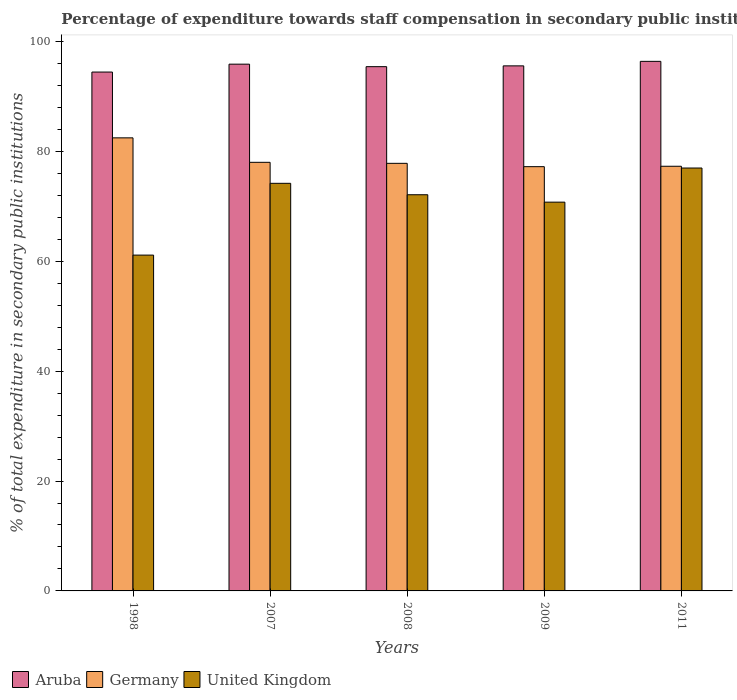How many different coloured bars are there?
Ensure brevity in your answer.  3. How many groups of bars are there?
Provide a short and direct response. 5. Are the number of bars on each tick of the X-axis equal?
Offer a terse response. Yes. How many bars are there on the 2nd tick from the left?
Provide a short and direct response. 3. What is the label of the 4th group of bars from the left?
Offer a very short reply. 2009. What is the percentage of expenditure towards staff compensation in Germany in 2009?
Offer a terse response. 77.21. Across all years, what is the maximum percentage of expenditure towards staff compensation in United Kingdom?
Keep it short and to the point. 76.96. Across all years, what is the minimum percentage of expenditure towards staff compensation in Aruba?
Keep it short and to the point. 94.42. In which year was the percentage of expenditure towards staff compensation in Aruba maximum?
Make the answer very short. 2011. What is the total percentage of expenditure towards staff compensation in United Kingdom in the graph?
Ensure brevity in your answer.  355.1. What is the difference between the percentage of expenditure towards staff compensation in Aruba in 2008 and that in 2009?
Your answer should be very brief. -0.15. What is the difference between the percentage of expenditure towards staff compensation in Germany in 2011 and the percentage of expenditure towards staff compensation in Aruba in 2008?
Provide a succinct answer. -18.12. What is the average percentage of expenditure towards staff compensation in United Kingdom per year?
Offer a very short reply. 71.02. In the year 2008, what is the difference between the percentage of expenditure towards staff compensation in United Kingdom and percentage of expenditure towards staff compensation in Germany?
Your answer should be very brief. -5.71. In how many years, is the percentage of expenditure towards staff compensation in United Kingdom greater than 32 %?
Your answer should be compact. 5. What is the ratio of the percentage of expenditure towards staff compensation in Germany in 2007 to that in 2008?
Your response must be concise. 1. Is the percentage of expenditure towards staff compensation in Aruba in 2008 less than that in 2011?
Provide a short and direct response. Yes. What is the difference between the highest and the second highest percentage of expenditure towards staff compensation in United Kingdom?
Provide a short and direct response. 2.79. What is the difference between the highest and the lowest percentage of expenditure towards staff compensation in Aruba?
Ensure brevity in your answer.  1.95. Is the sum of the percentage of expenditure towards staff compensation in United Kingdom in 2008 and 2011 greater than the maximum percentage of expenditure towards staff compensation in Aruba across all years?
Offer a terse response. Yes. What does the 1st bar from the left in 2009 represents?
Offer a terse response. Aruba. How many bars are there?
Provide a short and direct response. 15. Where does the legend appear in the graph?
Keep it short and to the point. Bottom left. What is the title of the graph?
Your response must be concise. Percentage of expenditure towards staff compensation in secondary public institutions. Does "Liechtenstein" appear as one of the legend labels in the graph?
Provide a short and direct response. No. What is the label or title of the Y-axis?
Your answer should be very brief. % of total expenditure in secondary public institutions. What is the % of total expenditure in secondary public institutions in Aruba in 1998?
Make the answer very short. 94.42. What is the % of total expenditure in secondary public institutions in Germany in 1998?
Offer a very short reply. 82.45. What is the % of total expenditure in secondary public institutions of United Kingdom in 1998?
Provide a short and direct response. 61.11. What is the % of total expenditure in secondary public institutions of Aruba in 2007?
Give a very brief answer. 95.86. What is the % of total expenditure in secondary public institutions in Germany in 2007?
Your answer should be very brief. 78. What is the % of total expenditure in secondary public institutions of United Kingdom in 2007?
Give a very brief answer. 74.18. What is the % of total expenditure in secondary public institutions of Aruba in 2008?
Offer a terse response. 95.41. What is the % of total expenditure in secondary public institutions of Germany in 2008?
Provide a short and direct response. 77.81. What is the % of total expenditure in secondary public institutions of United Kingdom in 2008?
Keep it short and to the point. 72.1. What is the % of total expenditure in secondary public institutions in Aruba in 2009?
Give a very brief answer. 95.55. What is the % of total expenditure in secondary public institutions of Germany in 2009?
Keep it short and to the point. 77.21. What is the % of total expenditure in secondary public institutions of United Kingdom in 2009?
Offer a very short reply. 70.75. What is the % of total expenditure in secondary public institutions in Aruba in 2011?
Your response must be concise. 96.37. What is the % of total expenditure in secondary public institutions of Germany in 2011?
Provide a succinct answer. 77.28. What is the % of total expenditure in secondary public institutions in United Kingdom in 2011?
Your answer should be compact. 76.96. Across all years, what is the maximum % of total expenditure in secondary public institutions of Aruba?
Make the answer very short. 96.37. Across all years, what is the maximum % of total expenditure in secondary public institutions in Germany?
Offer a very short reply. 82.45. Across all years, what is the maximum % of total expenditure in secondary public institutions of United Kingdom?
Ensure brevity in your answer.  76.96. Across all years, what is the minimum % of total expenditure in secondary public institutions of Aruba?
Offer a very short reply. 94.42. Across all years, what is the minimum % of total expenditure in secondary public institutions of Germany?
Your response must be concise. 77.21. Across all years, what is the minimum % of total expenditure in secondary public institutions of United Kingdom?
Provide a short and direct response. 61.11. What is the total % of total expenditure in secondary public institutions of Aruba in the graph?
Give a very brief answer. 477.61. What is the total % of total expenditure in secondary public institutions of Germany in the graph?
Your answer should be compact. 392.75. What is the total % of total expenditure in secondary public institutions of United Kingdom in the graph?
Your response must be concise. 355.1. What is the difference between the % of total expenditure in secondary public institutions of Aruba in 1998 and that in 2007?
Ensure brevity in your answer.  -1.44. What is the difference between the % of total expenditure in secondary public institutions in Germany in 1998 and that in 2007?
Your response must be concise. 4.45. What is the difference between the % of total expenditure in secondary public institutions of United Kingdom in 1998 and that in 2007?
Your answer should be very brief. -13.06. What is the difference between the % of total expenditure in secondary public institutions of Aruba in 1998 and that in 2008?
Make the answer very short. -0.98. What is the difference between the % of total expenditure in secondary public institutions in Germany in 1998 and that in 2008?
Give a very brief answer. 4.64. What is the difference between the % of total expenditure in secondary public institutions in United Kingdom in 1998 and that in 2008?
Make the answer very short. -10.99. What is the difference between the % of total expenditure in secondary public institutions of Aruba in 1998 and that in 2009?
Make the answer very short. -1.13. What is the difference between the % of total expenditure in secondary public institutions in Germany in 1998 and that in 2009?
Offer a terse response. 5.24. What is the difference between the % of total expenditure in secondary public institutions in United Kingdom in 1998 and that in 2009?
Your answer should be compact. -9.64. What is the difference between the % of total expenditure in secondary public institutions of Aruba in 1998 and that in 2011?
Provide a short and direct response. -1.95. What is the difference between the % of total expenditure in secondary public institutions of Germany in 1998 and that in 2011?
Your response must be concise. 5.17. What is the difference between the % of total expenditure in secondary public institutions of United Kingdom in 1998 and that in 2011?
Offer a terse response. -15.85. What is the difference between the % of total expenditure in secondary public institutions of Aruba in 2007 and that in 2008?
Offer a terse response. 0.46. What is the difference between the % of total expenditure in secondary public institutions of Germany in 2007 and that in 2008?
Your answer should be very brief. 0.18. What is the difference between the % of total expenditure in secondary public institutions of United Kingdom in 2007 and that in 2008?
Your answer should be very brief. 2.08. What is the difference between the % of total expenditure in secondary public institutions of Aruba in 2007 and that in 2009?
Make the answer very short. 0.31. What is the difference between the % of total expenditure in secondary public institutions of Germany in 2007 and that in 2009?
Make the answer very short. 0.79. What is the difference between the % of total expenditure in secondary public institutions of United Kingdom in 2007 and that in 2009?
Make the answer very short. 3.43. What is the difference between the % of total expenditure in secondary public institutions of Aruba in 2007 and that in 2011?
Offer a terse response. -0.51. What is the difference between the % of total expenditure in secondary public institutions of Germany in 2007 and that in 2011?
Offer a terse response. 0.72. What is the difference between the % of total expenditure in secondary public institutions of United Kingdom in 2007 and that in 2011?
Keep it short and to the point. -2.79. What is the difference between the % of total expenditure in secondary public institutions in Aruba in 2008 and that in 2009?
Keep it short and to the point. -0.15. What is the difference between the % of total expenditure in secondary public institutions in Germany in 2008 and that in 2009?
Your answer should be compact. 0.61. What is the difference between the % of total expenditure in secondary public institutions in United Kingdom in 2008 and that in 2009?
Offer a terse response. 1.35. What is the difference between the % of total expenditure in secondary public institutions in Aruba in 2008 and that in 2011?
Your response must be concise. -0.97. What is the difference between the % of total expenditure in secondary public institutions of Germany in 2008 and that in 2011?
Provide a succinct answer. 0.53. What is the difference between the % of total expenditure in secondary public institutions of United Kingdom in 2008 and that in 2011?
Give a very brief answer. -4.86. What is the difference between the % of total expenditure in secondary public institutions of Aruba in 2009 and that in 2011?
Keep it short and to the point. -0.82. What is the difference between the % of total expenditure in secondary public institutions in Germany in 2009 and that in 2011?
Make the answer very short. -0.07. What is the difference between the % of total expenditure in secondary public institutions in United Kingdom in 2009 and that in 2011?
Provide a short and direct response. -6.21. What is the difference between the % of total expenditure in secondary public institutions in Aruba in 1998 and the % of total expenditure in secondary public institutions in Germany in 2007?
Your response must be concise. 16.43. What is the difference between the % of total expenditure in secondary public institutions of Aruba in 1998 and the % of total expenditure in secondary public institutions of United Kingdom in 2007?
Offer a very short reply. 20.25. What is the difference between the % of total expenditure in secondary public institutions in Germany in 1998 and the % of total expenditure in secondary public institutions in United Kingdom in 2007?
Your answer should be compact. 8.28. What is the difference between the % of total expenditure in secondary public institutions in Aruba in 1998 and the % of total expenditure in secondary public institutions in Germany in 2008?
Make the answer very short. 16.61. What is the difference between the % of total expenditure in secondary public institutions of Aruba in 1998 and the % of total expenditure in secondary public institutions of United Kingdom in 2008?
Offer a very short reply. 22.33. What is the difference between the % of total expenditure in secondary public institutions of Germany in 1998 and the % of total expenditure in secondary public institutions of United Kingdom in 2008?
Your answer should be compact. 10.35. What is the difference between the % of total expenditure in secondary public institutions of Aruba in 1998 and the % of total expenditure in secondary public institutions of Germany in 2009?
Your response must be concise. 17.22. What is the difference between the % of total expenditure in secondary public institutions of Aruba in 1998 and the % of total expenditure in secondary public institutions of United Kingdom in 2009?
Your answer should be compact. 23.68. What is the difference between the % of total expenditure in secondary public institutions in Germany in 1998 and the % of total expenditure in secondary public institutions in United Kingdom in 2009?
Your answer should be very brief. 11.7. What is the difference between the % of total expenditure in secondary public institutions in Aruba in 1998 and the % of total expenditure in secondary public institutions in Germany in 2011?
Keep it short and to the point. 17.14. What is the difference between the % of total expenditure in secondary public institutions of Aruba in 1998 and the % of total expenditure in secondary public institutions of United Kingdom in 2011?
Keep it short and to the point. 17.46. What is the difference between the % of total expenditure in secondary public institutions in Germany in 1998 and the % of total expenditure in secondary public institutions in United Kingdom in 2011?
Your response must be concise. 5.49. What is the difference between the % of total expenditure in secondary public institutions in Aruba in 2007 and the % of total expenditure in secondary public institutions in Germany in 2008?
Offer a terse response. 18.05. What is the difference between the % of total expenditure in secondary public institutions in Aruba in 2007 and the % of total expenditure in secondary public institutions in United Kingdom in 2008?
Your answer should be compact. 23.76. What is the difference between the % of total expenditure in secondary public institutions of Germany in 2007 and the % of total expenditure in secondary public institutions of United Kingdom in 2008?
Give a very brief answer. 5.9. What is the difference between the % of total expenditure in secondary public institutions of Aruba in 2007 and the % of total expenditure in secondary public institutions of Germany in 2009?
Keep it short and to the point. 18.65. What is the difference between the % of total expenditure in secondary public institutions of Aruba in 2007 and the % of total expenditure in secondary public institutions of United Kingdom in 2009?
Provide a short and direct response. 25.11. What is the difference between the % of total expenditure in secondary public institutions in Germany in 2007 and the % of total expenditure in secondary public institutions in United Kingdom in 2009?
Provide a short and direct response. 7.25. What is the difference between the % of total expenditure in secondary public institutions in Aruba in 2007 and the % of total expenditure in secondary public institutions in Germany in 2011?
Your response must be concise. 18.58. What is the difference between the % of total expenditure in secondary public institutions in Aruba in 2007 and the % of total expenditure in secondary public institutions in United Kingdom in 2011?
Your answer should be very brief. 18.9. What is the difference between the % of total expenditure in secondary public institutions in Germany in 2007 and the % of total expenditure in secondary public institutions in United Kingdom in 2011?
Your response must be concise. 1.04. What is the difference between the % of total expenditure in secondary public institutions of Aruba in 2008 and the % of total expenditure in secondary public institutions of Germany in 2009?
Provide a succinct answer. 18.2. What is the difference between the % of total expenditure in secondary public institutions in Aruba in 2008 and the % of total expenditure in secondary public institutions in United Kingdom in 2009?
Make the answer very short. 24.66. What is the difference between the % of total expenditure in secondary public institutions in Germany in 2008 and the % of total expenditure in secondary public institutions in United Kingdom in 2009?
Your answer should be compact. 7.06. What is the difference between the % of total expenditure in secondary public institutions of Aruba in 2008 and the % of total expenditure in secondary public institutions of Germany in 2011?
Your response must be concise. 18.12. What is the difference between the % of total expenditure in secondary public institutions of Aruba in 2008 and the % of total expenditure in secondary public institutions of United Kingdom in 2011?
Your answer should be very brief. 18.45. What is the difference between the % of total expenditure in secondary public institutions in Germany in 2008 and the % of total expenditure in secondary public institutions in United Kingdom in 2011?
Offer a very short reply. 0.85. What is the difference between the % of total expenditure in secondary public institutions of Aruba in 2009 and the % of total expenditure in secondary public institutions of Germany in 2011?
Make the answer very short. 18.27. What is the difference between the % of total expenditure in secondary public institutions of Aruba in 2009 and the % of total expenditure in secondary public institutions of United Kingdom in 2011?
Provide a short and direct response. 18.59. What is the difference between the % of total expenditure in secondary public institutions in Germany in 2009 and the % of total expenditure in secondary public institutions in United Kingdom in 2011?
Keep it short and to the point. 0.25. What is the average % of total expenditure in secondary public institutions in Aruba per year?
Your answer should be compact. 95.52. What is the average % of total expenditure in secondary public institutions in Germany per year?
Provide a short and direct response. 78.55. What is the average % of total expenditure in secondary public institutions in United Kingdom per year?
Offer a very short reply. 71.02. In the year 1998, what is the difference between the % of total expenditure in secondary public institutions of Aruba and % of total expenditure in secondary public institutions of Germany?
Keep it short and to the point. 11.97. In the year 1998, what is the difference between the % of total expenditure in secondary public institutions in Aruba and % of total expenditure in secondary public institutions in United Kingdom?
Offer a terse response. 33.31. In the year 1998, what is the difference between the % of total expenditure in secondary public institutions in Germany and % of total expenditure in secondary public institutions in United Kingdom?
Provide a succinct answer. 21.34. In the year 2007, what is the difference between the % of total expenditure in secondary public institutions in Aruba and % of total expenditure in secondary public institutions in Germany?
Your answer should be very brief. 17.86. In the year 2007, what is the difference between the % of total expenditure in secondary public institutions of Aruba and % of total expenditure in secondary public institutions of United Kingdom?
Keep it short and to the point. 21.69. In the year 2007, what is the difference between the % of total expenditure in secondary public institutions of Germany and % of total expenditure in secondary public institutions of United Kingdom?
Your response must be concise. 3.82. In the year 2008, what is the difference between the % of total expenditure in secondary public institutions in Aruba and % of total expenditure in secondary public institutions in Germany?
Your answer should be compact. 17.59. In the year 2008, what is the difference between the % of total expenditure in secondary public institutions of Aruba and % of total expenditure in secondary public institutions of United Kingdom?
Give a very brief answer. 23.31. In the year 2008, what is the difference between the % of total expenditure in secondary public institutions of Germany and % of total expenditure in secondary public institutions of United Kingdom?
Offer a very short reply. 5.71. In the year 2009, what is the difference between the % of total expenditure in secondary public institutions of Aruba and % of total expenditure in secondary public institutions of Germany?
Offer a terse response. 18.34. In the year 2009, what is the difference between the % of total expenditure in secondary public institutions of Aruba and % of total expenditure in secondary public institutions of United Kingdom?
Make the answer very short. 24.8. In the year 2009, what is the difference between the % of total expenditure in secondary public institutions of Germany and % of total expenditure in secondary public institutions of United Kingdom?
Your answer should be compact. 6.46. In the year 2011, what is the difference between the % of total expenditure in secondary public institutions in Aruba and % of total expenditure in secondary public institutions in Germany?
Your answer should be compact. 19.09. In the year 2011, what is the difference between the % of total expenditure in secondary public institutions in Aruba and % of total expenditure in secondary public institutions in United Kingdom?
Provide a short and direct response. 19.41. In the year 2011, what is the difference between the % of total expenditure in secondary public institutions in Germany and % of total expenditure in secondary public institutions in United Kingdom?
Offer a terse response. 0.32. What is the ratio of the % of total expenditure in secondary public institutions of Aruba in 1998 to that in 2007?
Your answer should be compact. 0.98. What is the ratio of the % of total expenditure in secondary public institutions in Germany in 1998 to that in 2007?
Offer a very short reply. 1.06. What is the ratio of the % of total expenditure in secondary public institutions in United Kingdom in 1998 to that in 2007?
Offer a very short reply. 0.82. What is the ratio of the % of total expenditure in secondary public institutions of Aruba in 1998 to that in 2008?
Provide a succinct answer. 0.99. What is the ratio of the % of total expenditure in secondary public institutions in Germany in 1998 to that in 2008?
Provide a short and direct response. 1.06. What is the ratio of the % of total expenditure in secondary public institutions of United Kingdom in 1998 to that in 2008?
Your answer should be compact. 0.85. What is the ratio of the % of total expenditure in secondary public institutions of Germany in 1998 to that in 2009?
Make the answer very short. 1.07. What is the ratio of the % of total expenditure in secondary public institutions in United Kingdom in 1998 to that in 2009?
Keep it short and to the point. 0.86. What is the ratio of the % of total expenditure in secondary public institutions in Aruba in 1998 to that in 2011?
Your answer should be very brief. 0.98. What is the ratio of the % of total expenditure in secondary public institutions of Germany in 1998 to that in 2011?
Your answer should be compact. 1.07. What is the ratio of the % of total expenditure in secondary public institutions in United Kingdom in 1998 to that in 2011?
Give a very brief answer. 0.79. What is the ratio of the % of total expenditure in secondary public institutions in Aruba in 2007 to that in 2008?
Ensure brevity in your answer.  1. What is the ratio of the % of total expenditure in secondary public institutions of Germany in 2007 to that in 2008?
Make the answer very short. 1. What is the ratio of the % of total expenditure in secondary public institutions in United Kingdom in 2007 to that in 2008?
Ensure brevity in your answer.  1.03. What is the ratio of the % of total expenditure in secondary public institutions in Aruba in 2007 to that in 2009?
Provide a succinct answer. 1. What is the ratio of the % of total expenditure in secondary public institutions of Germany in 2007 to that in 2009?
Offer a terse response. 1.01. What is the ratio of the % of total expenditure in secondary public institutions in United Kingdom in 2007 to that in 2009?
Your response must be concise. 1.05. What is the ratio of the % of total expenditure in secondary public institutions in Aruba in 2007 to that in 2011?
Keep it short and to the point. 0.99. What is the ratio of the % of total expenditure in secondary public institutions in Germany in 2007 to that in 2011?
Ensure brevity in your answer.  1.01. What is the ratio of the % of total expenditure in secondary public institutions in United Kingdom in 2007 to that in 2011?
Make the answer very short. 0.96. What is the ratio of the % of total expenditure in secondary public institutions in Germany in 2008 to that in 2009?
Ensure brevity in your answer.  1.01. What is the ratio of the % of total expenditure in secondary public institutions of United Kingdom in 2008 to that in 2009?
Give a very brief answer. 1.02. What is the ratio of the % of total expenditure in secondary public institutions in Aruba in 2008 to that in 2011?
Ensure brevity in your answer.  0.99. What is the ratio of the % of total expenditure in secondary public institutions in United Kingdom in 2008 to that in 2011?
Your answer should be compact. 0.94. What is the ratio of the % of total expenditure in secondary public institutions of Aruba in 2009 to that in 2011?
Your answer should be compact. 0.99. What is the ratio of the % of total expenditure in secondary public institutions in Germany in 2009 to that in 2011?
Your response must be concise. 1. What is the ratio of the % of total expenditure in secondary public institutions in United Kingdom in 2009 to that in 2011?
Your answer should be very brief. 0.92. What is the difference between the highest and the second highest % of total expenditure in secondary public institutions of Aruba?
Provide a short and direct response. 0.51. What is the difference between the highest and the second highest % of total expenditure in secondary public institutions of Germany?
Your response must be concise. 4.45. What is the difference between the highest and the second highest % of total expenditure in secondary public institutions in United Kingdom?
Keep it short and to the point. 2.79. What is the difference between the highest and the lowest % of total expenditure in secondary public institutions of Aruba?
Make the answer very short. 1.95. What is the difference between the highest and the lowest % of total expenditure in secondary public institutions in Germany?
Ensure brevity in your answer.  5.24. What is the difference between the highest and the lowest % of total expenditure in secondary public institutions of United Kingdom?
Your answer should be very brief. 15.85. 